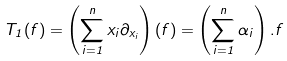<formula> <loc_0><loc_0><loc_500><loc_500>{ T _ { 1 } } ( f ) = \left ( \sum _ { i = 1 } ^ { n } { x _ { i } \partial _ { x _ { i } } } \right ) ( f ) = \left ( \sum _ { i = 1 } ^ { n } { \alpha _ { i } } \right ) . f</formula> 